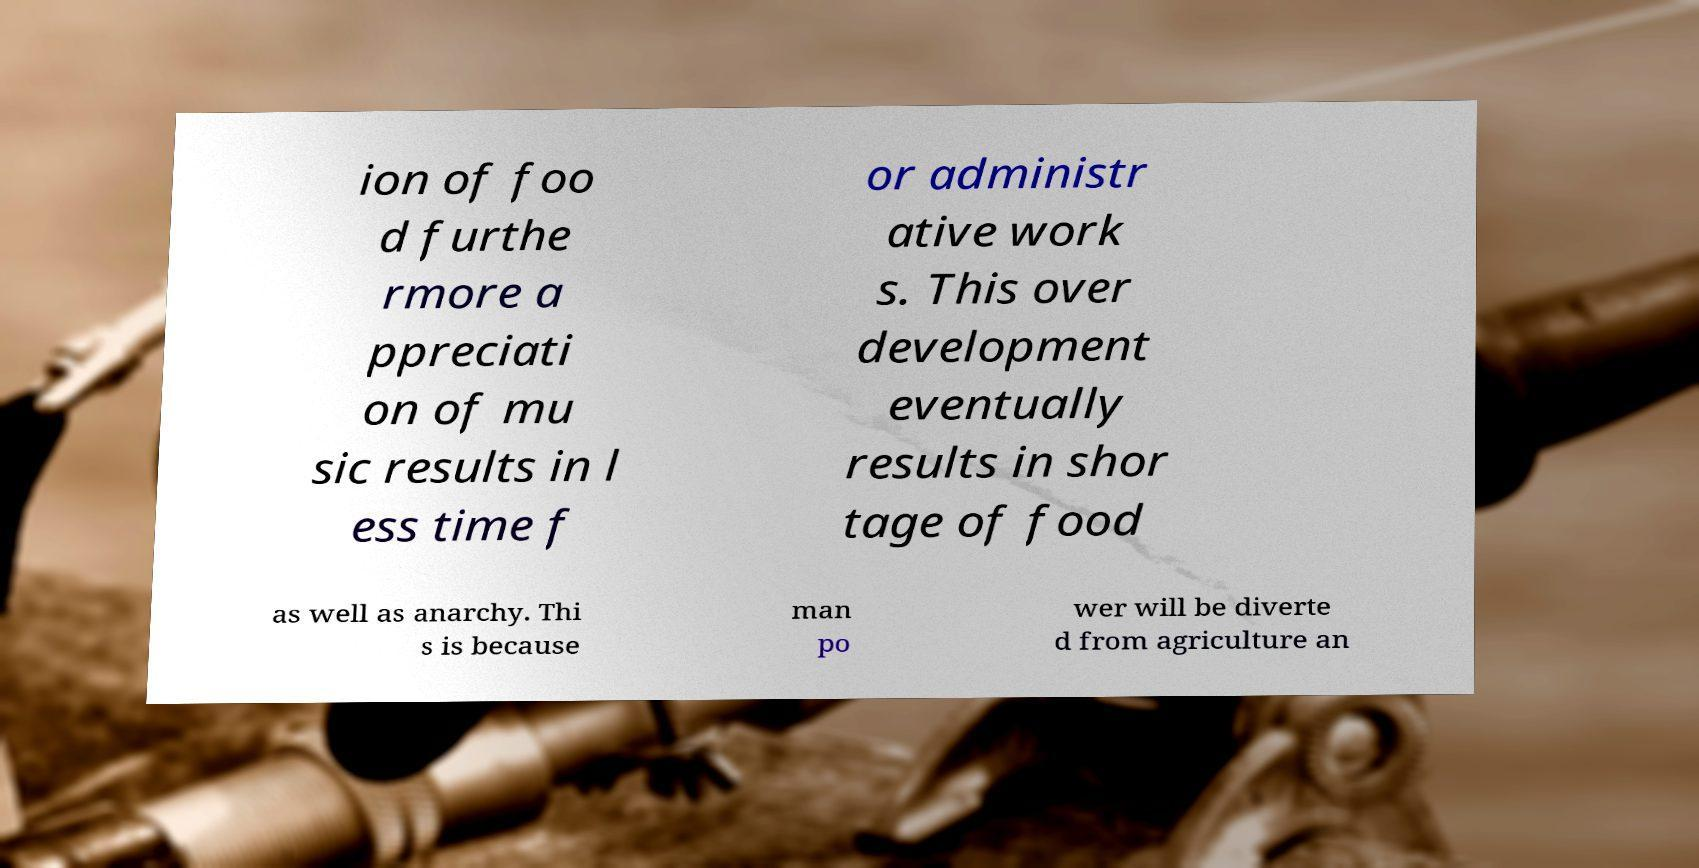For documentation purposes, I need the text within this image transcribed. Could you provide that? ion of foo d furthe rmore a ppreciati on of mu sic results in l ess time f or administr ative work s. This over development eventually results in shor tage of food as well as anarchy. Thi s is because man po wer will be diverte d from agriculture an 